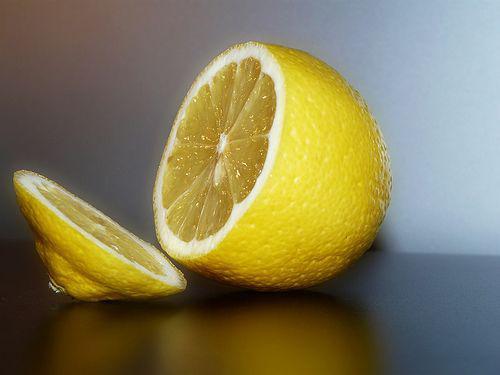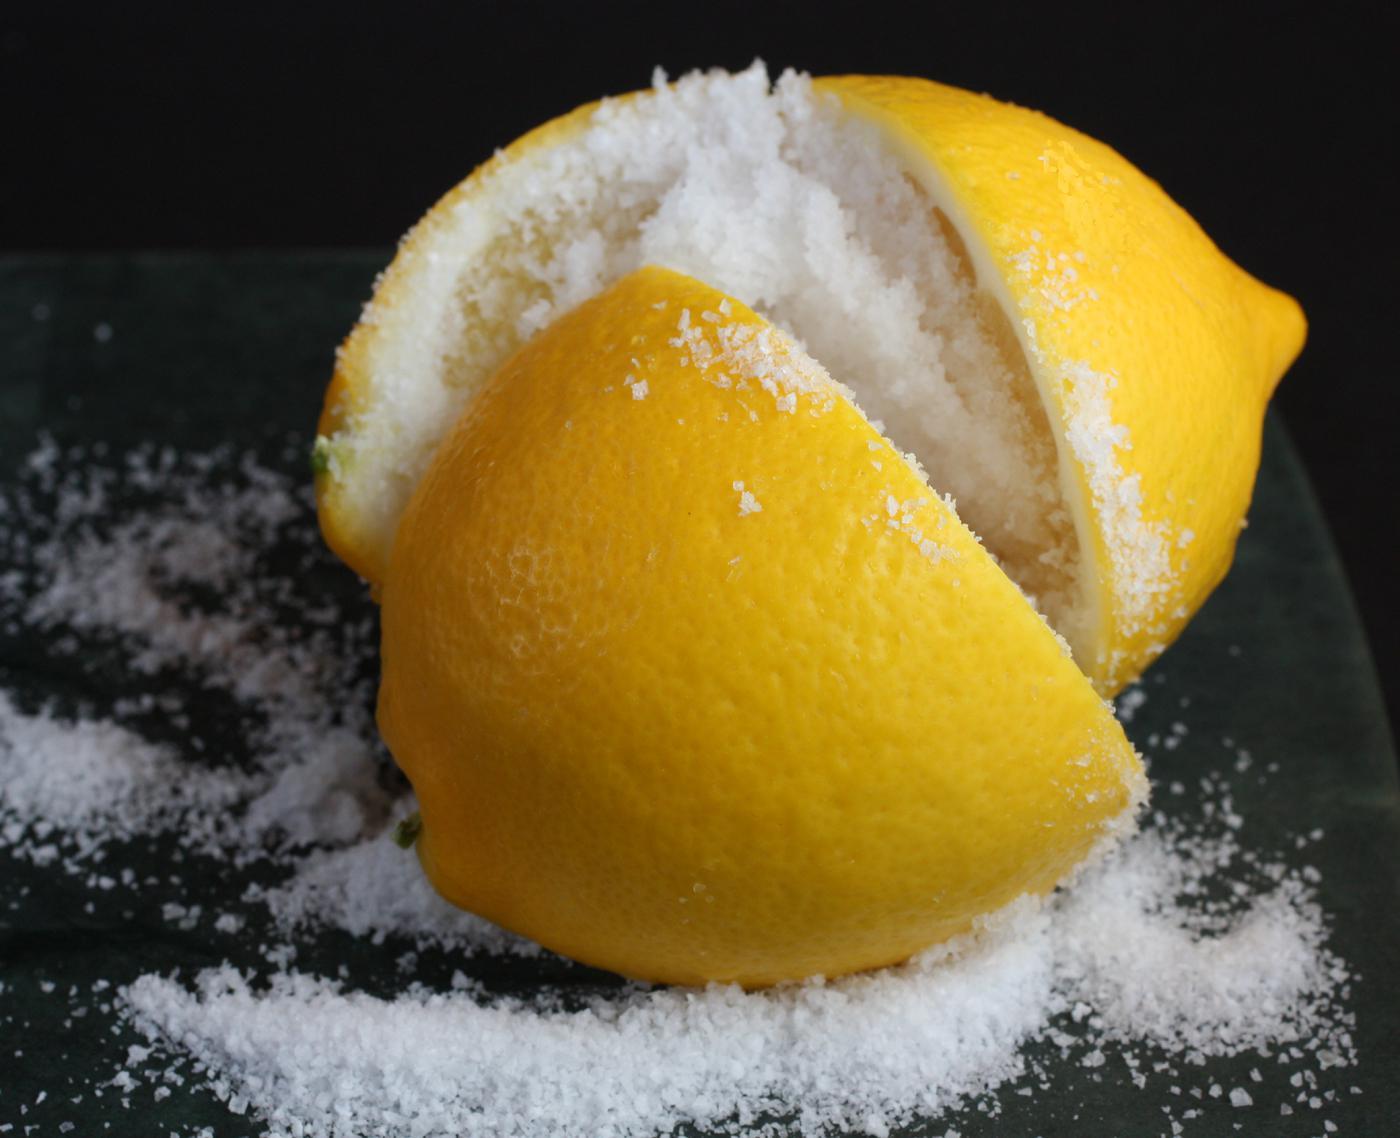The first image is the image on the left, the second image is the image on the right. Considering the images on both sides, is "The left image contains at least one lemon with a criss-cross cut through the top filled with fine white grains." valid? Answer yes or no. No. The first image is the image on the left, the second image is the image on the right. Assess this claim about the two images: "In at least one image there are a total of four lemon slices.". Correct or not? Answer yes or no. No. 